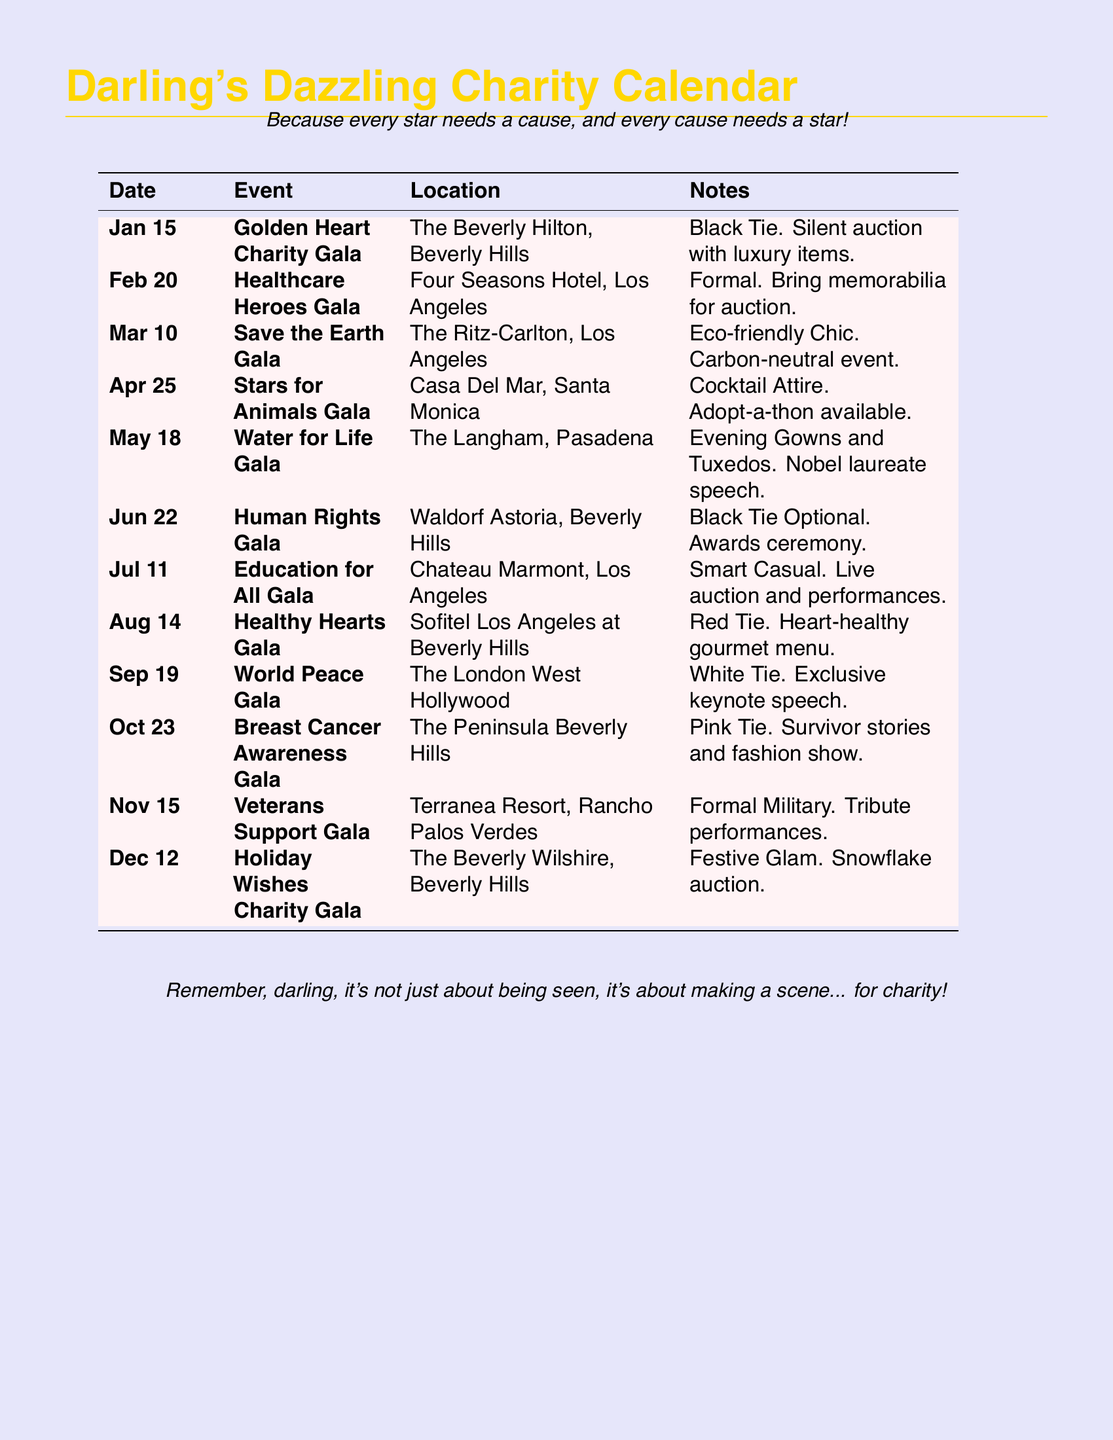What is the date of the Golden Heart Charity Gala? The date is specified in the document as Jan 15.
Answer: Jan 15 Where is the Healthcare Heroes Gala held? The location is listed as Four Seasons Hotel, Los Angeles.
Answer: Four Seasons Hotel, Los Angeles What type of attire is required for the Save the Earth Gala? The document states the attire as Eco-friendly Chic.
Answer: Eco-friendly Chic How many charity galas are scheduled in the month of June? The document shows one event, the Human Rights Gala, in June.
Answer: 1 What kind of event is the Stars for Animals Gala? The notes indicate it includes an Adopt-a-thon.
Answer: Adopt-a-thon Which gala has a Nobel laureate speech? The document specifies that the Water for Life Gala features the speech.
Answer: Water for Life Gala What is the theme of the World Peace Gala? The document indicates it requires White Tie attire and includes an exclusive keynote speech.
Answer: White Tie Is there an auction at the Education for All Gala? The notes mention there will be a live auction and performances.
Answer: Yes How many events have "Gala" in their title? The document lists twelve events that contain "Gala."
Answer: 12 